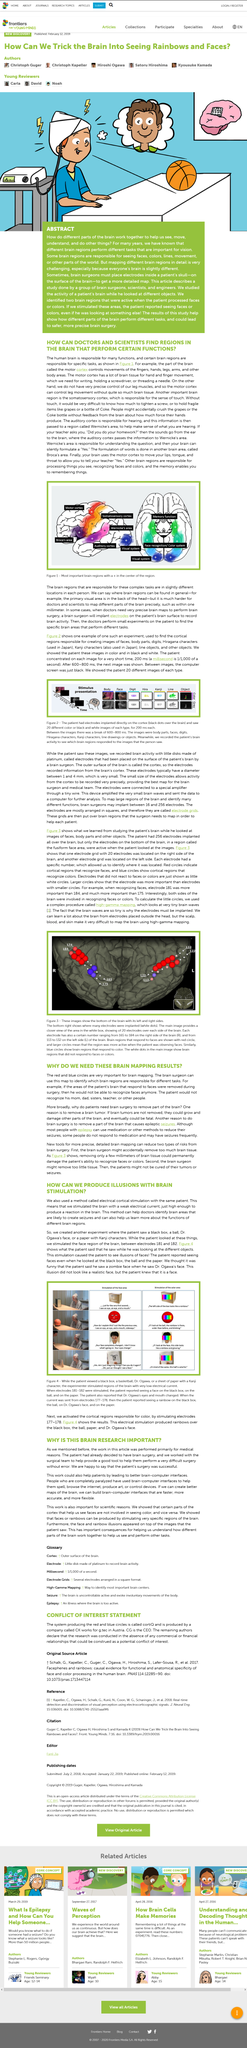List a handful of essential elements in this visual. Electrode grids are composed of electrodes arranged in squares, which are used to deliver electrical impulses to the brain for therapeutic purposes. In the given example, it was found that the electrode corresponding to face recognition was more important than the electrodes corresponding to points 184 and 181. The electrodes 181 and 182 on the black box were stimulated by a face. The somatosensory cortex is responsible for the sense of touch. Yes, the most important brain regions are indicated with a + sign. 